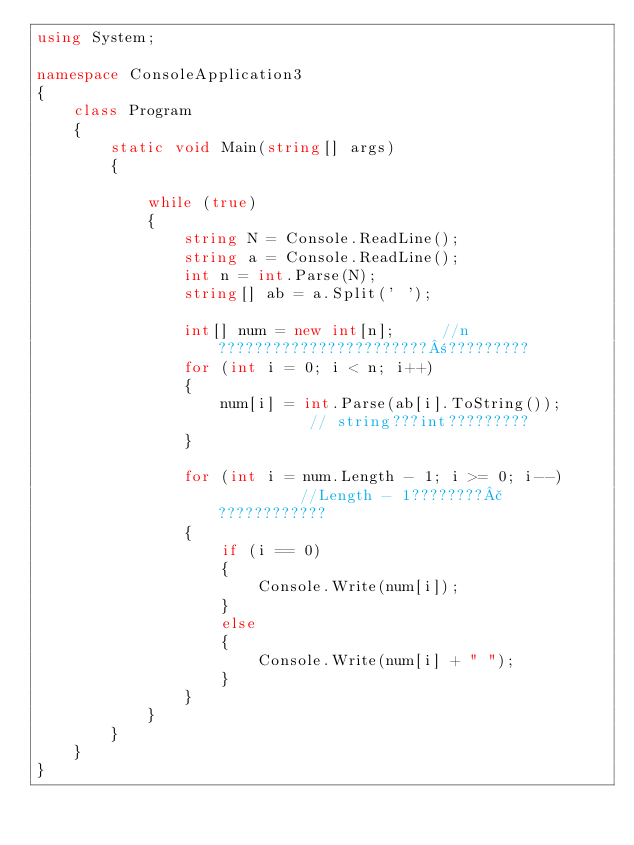Convert code to text. <code><loc_0><loc_0><loc_500><loc_500><_C#_>using System;

namespace ConsoleApplication3
{
    class Program
    {
        static void Main(string[] args)
        {

            while (true)
            {
                string N = Console.ReadLine();
                string a = Console.ReadLine();
                int n = int.Parse(N);
                string[] ab = a.Split(' ');

                int[] num = new int[n];     //n???????????????????????±?????????
                for (int i = 0; i < n; i++)
                {
                    num[i] = int.Parse(ab[i].ToString());       // string???int?????????
                }

                for (int i = num.Length - 1; i >= 0; i--)          //Length - 1????????£????????????
                {
                    if (i == 0)
                    {
                        Console.Write(num[i]);
                    }
                    else
                    {
                        Console.Write(num[i] + " ");
                    }
                }
            }
        }
    }
}</code> 